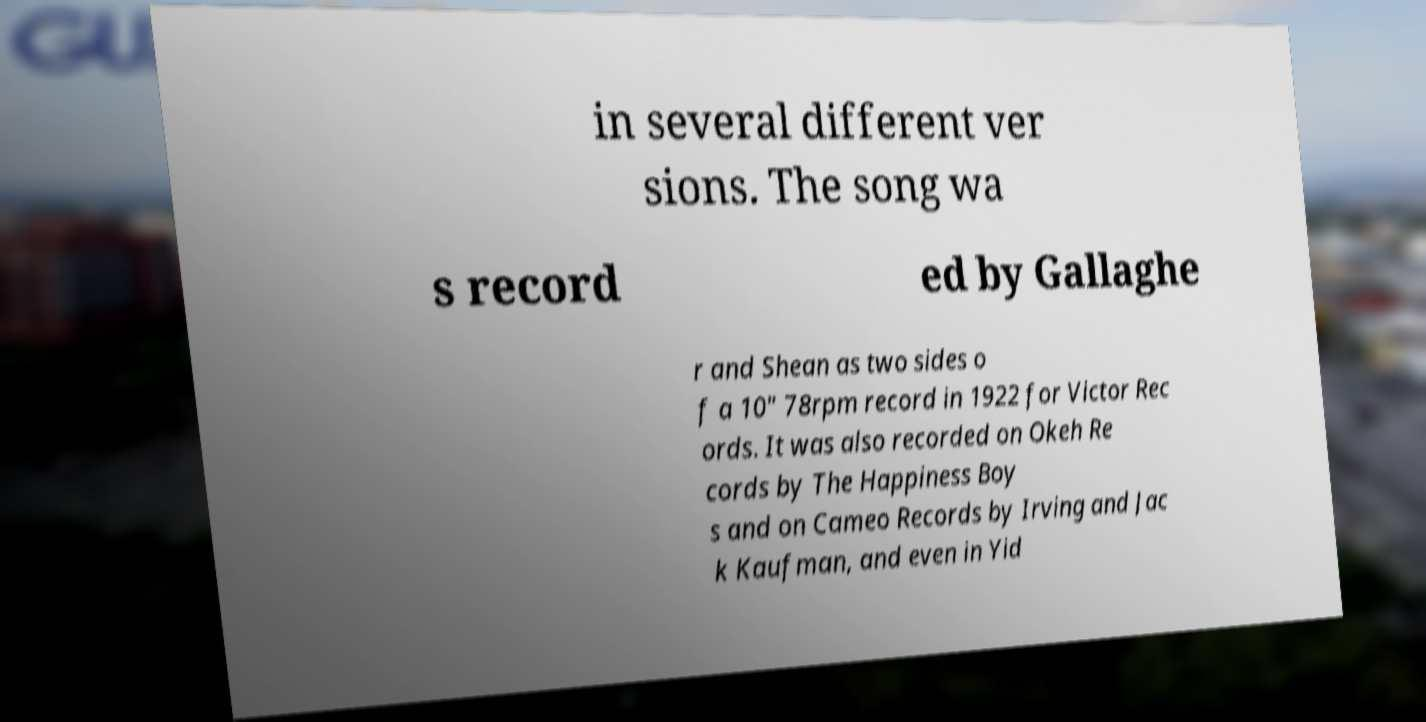Can you read and provide the text displayed in the image?This photo seems to have some interesting text. Can you extract and type it out for me? in several different ver sions. The song wa s record ed by Gallaghe r and Shean as two sides o f a 10" 78rpm record in 1922 for Victor Rec ords. It was also recorded on Okeh Re cords by The Happiness Boy s and on Cameo Records by Irving and Jac k Kaufman, and even in Yid 